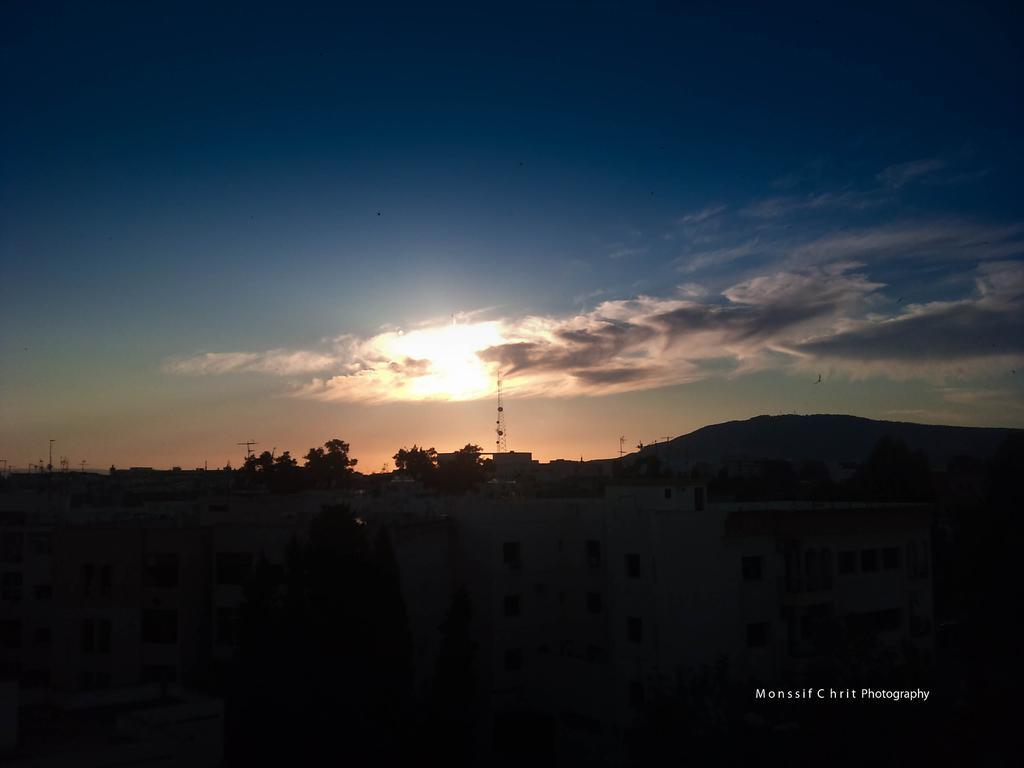In one or two sentences, can you explain what this image depicts? In this image there are buildings. In the background there are trees, poles and mountains. At the top there is the sky. In the bottom right there is text on the image. At the bottom of the image it is dark. 